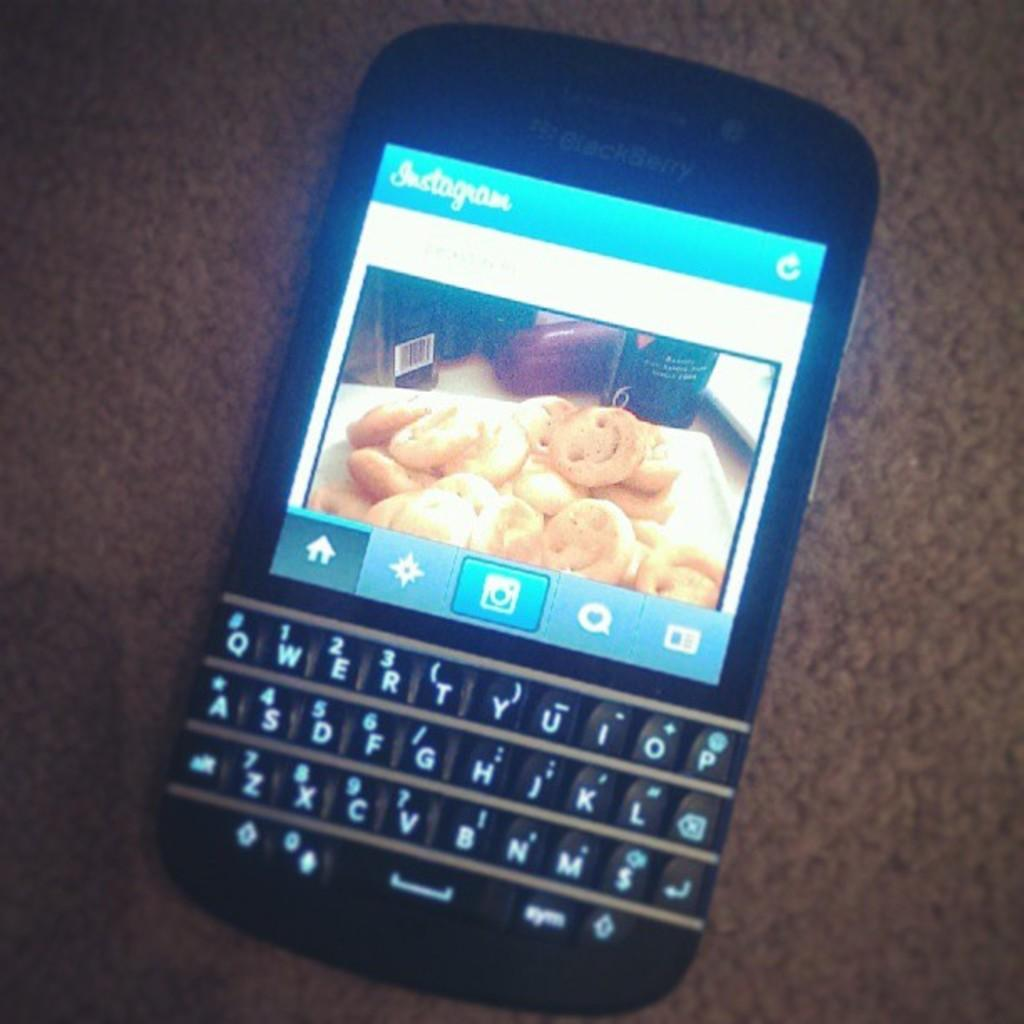<image>
Share a concise interpretation of the image provided. a photo of cookies on a phone that is on Instagram 